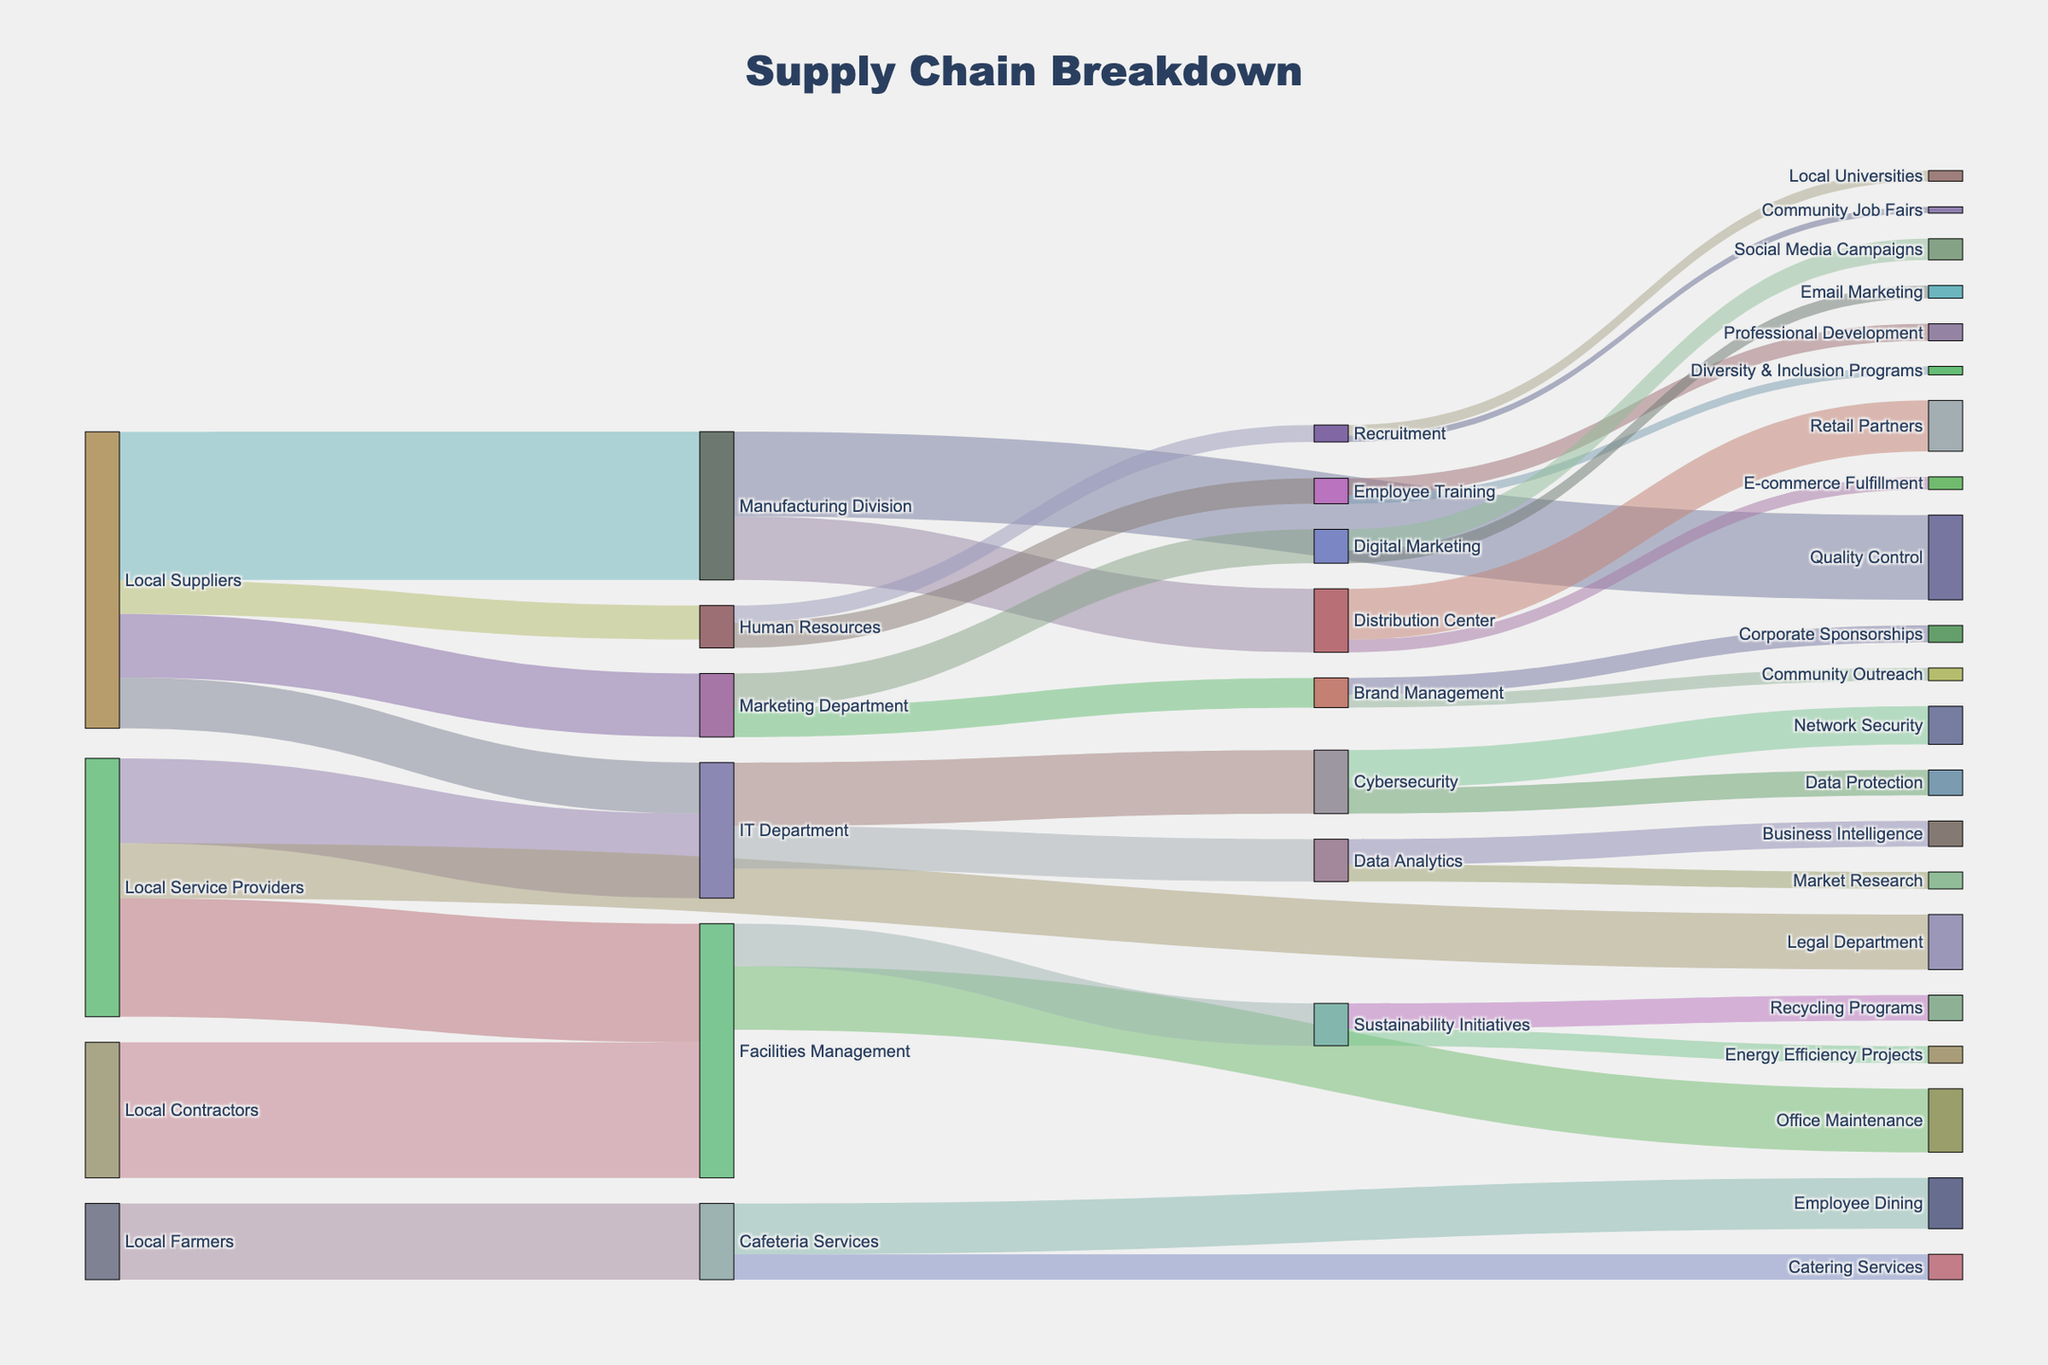How much supply does the Facilities Management receive from the Local Contractors and Local Service Providers? The Facilities Management receives 3200 from Local Contractors and 2800 from Local Service Providers. Summing these values gives 3200 + 2800.
Answer: 6000 Which division receives the highest flow of supplies from local businesses? The divisions receive the following supplies: Manufacturing Division (3500), IT Department (1200), Human Resources (800), Marketing Department (1500), Facilities Management (3200). The Manufacturing Division receives the highest flow at 3500.
Answer: Manufacturing Division What's the difference in supply flow between the Manufacturing Division and the IT Department from local sources? Manufacturing Division receives 3500, while the IT Department receives 1200. The difference is 3500 - 1200.
Answer: 2300 What are the main downstream departments from the IT Department and their supply contributions? The IT Department sends supplies to Cybersecurity (1500) and Data Analytics (1000).
Answer: Cybersecurity (1500), Data Analytics (1000) Which has a longer flow: Local Service Providers to Facilities Management or Cafeteria Services to Employee Dining? Local Service Providers to Facilities Management: 2800, Cafeteria Services to Employee Dining: 1200. 2800 is longer than 1200.
Answer: Local Service Providers to Facilities Management Calculate the average supply flow from local suppliers to company divisions. The values are Manufacturing Division (3500), IT Department (1200), Human Resources (800), Marketing Department (1500). Sum is 7000, and with 4 divisions, the average is 7000 / 4.
Answer: 1750 Compare the total supplies that the Cafeteria Services department manages versus the Facilities Management. Cafeteria Services handles Employee Dining (1200) + Catering Services (600) = 1800. Facilities Management handles Office Maintenance (1500) + Sustainability Initiatives (1000) = 2500. 2500 is greater than 1800.
Answer: Facilities Management Which department supports the most diverse range of downstream needs? Facilities Management supports Office Maintenance (1500) and Sustainability Initiatives (1000). All other departments support either 1 or 2 categories of needs with less variety.
Answer: Facilities Management What is the total flow from all local businesses to the IT Department? Sum values: Local Suppliers (1200) + Local Service Providers (2000). 1200 + 2000 = 3200.
Answer: 3200 